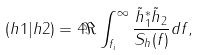<formula> <loc_0><loc_0><loc_500><loc_500>( h 1 | h 2 ) = 4 \Re \int ^ { \infty } _ { f _ { i } } \frac { \tilde { h } _ { 1 } ^ { * } \tilde { h } _ { 2 } } { S _ { h } ( f ) } d f ,</formula> 